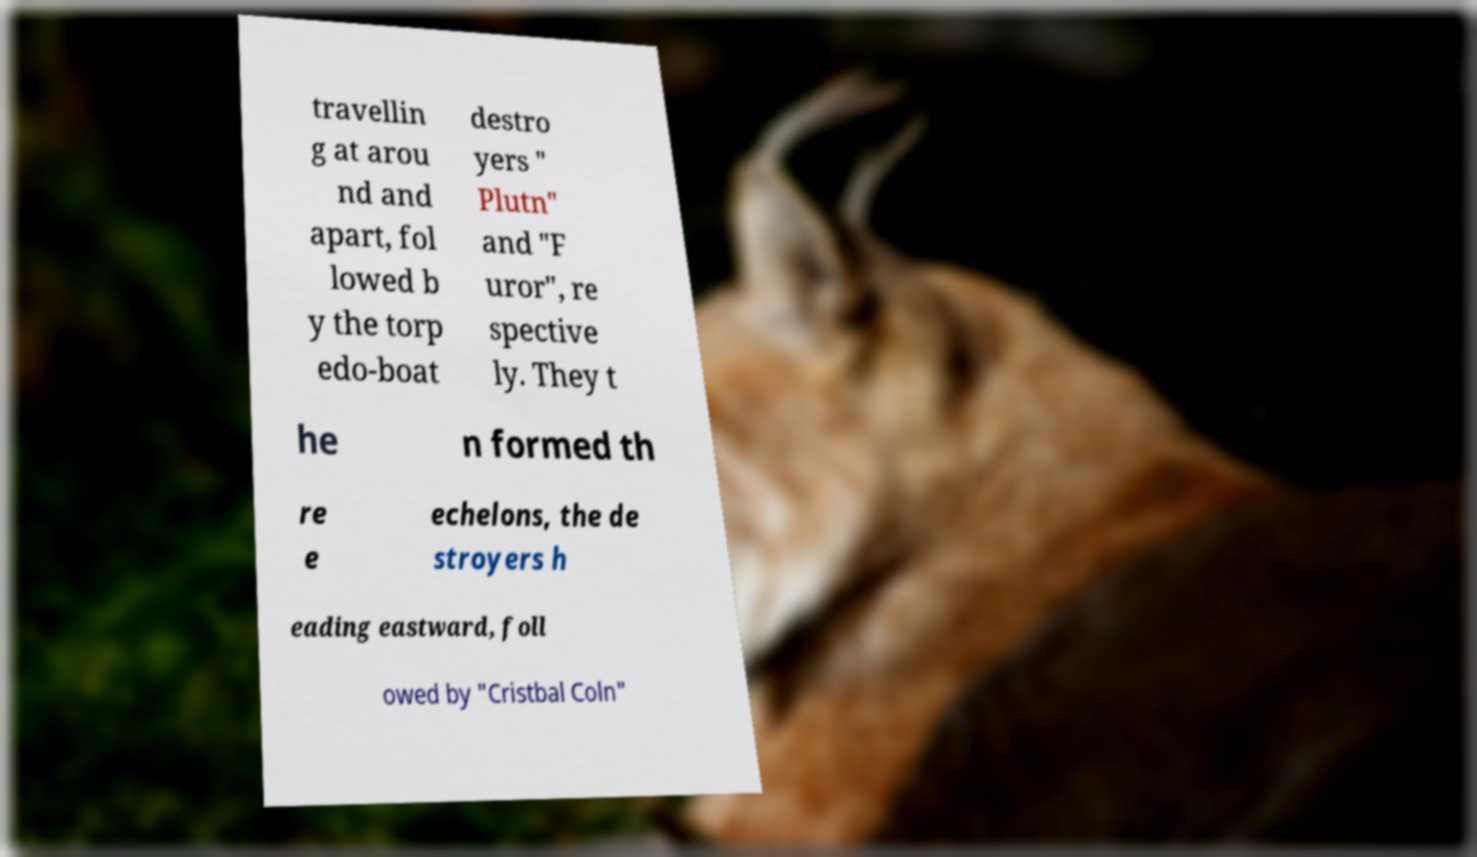Please read and relay the text visible in this image. What does it say? travellin g at arou nd and apart, fol lowed b y the torp edo-boat destro yers " Plutn" and "F uror", re spective ly. They t he n formed th re e echelons, the de stroyers h eading eastward, foll owed by "Cristbal Coln" 